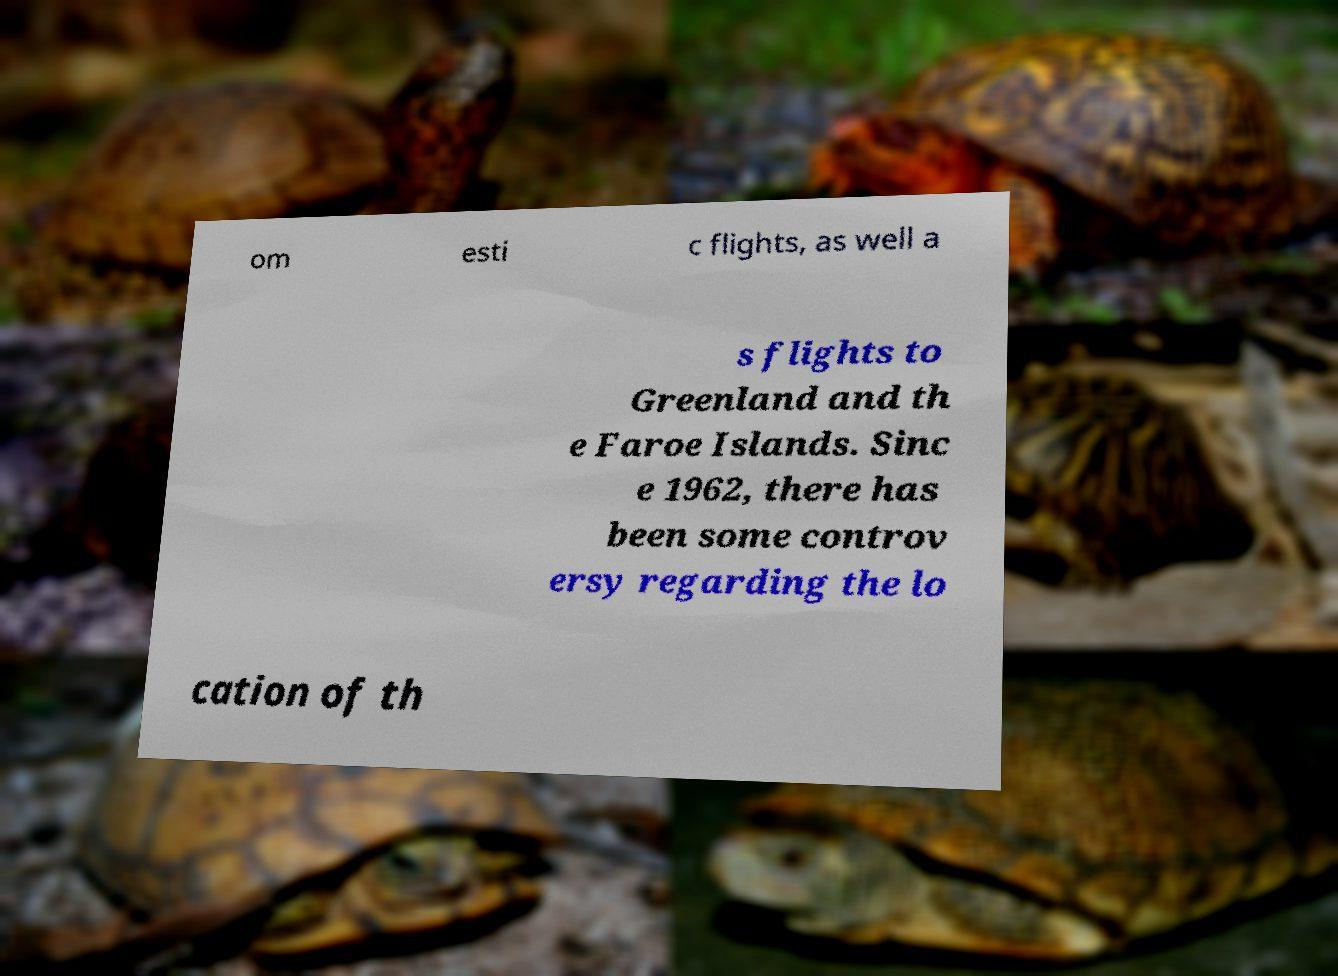For documentation purposes, I need the text within this image transcribed. Could you provide that? om esti c flights, as well a s flights to Greenland and th e Faroe Islands. Sinc e 1962, there has been some controv ersy regarding the lo cation of th 